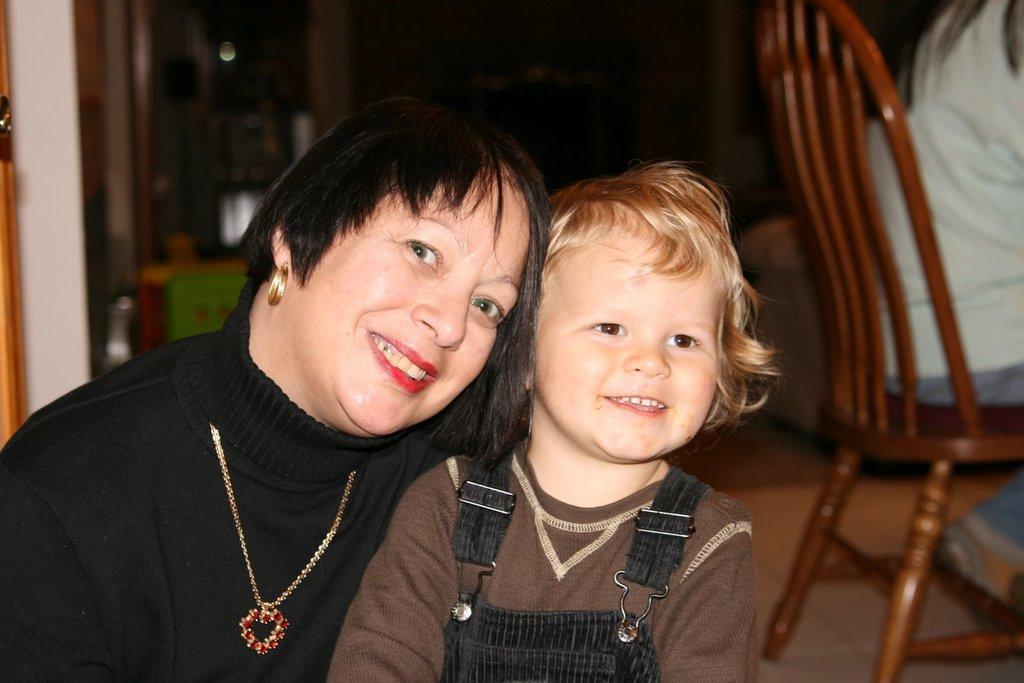How would you summarize this image in a sentence or two? In this image I can see the two people are smiling. To the right there is a person sitting on the chair. 